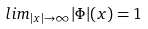Convert formula to latex. <formula><loc_0><loc_0><loc_500><loc_500>l i m _ { | x | \rightarrow \infty } | \Phi | ( x ) = 1</formula> 